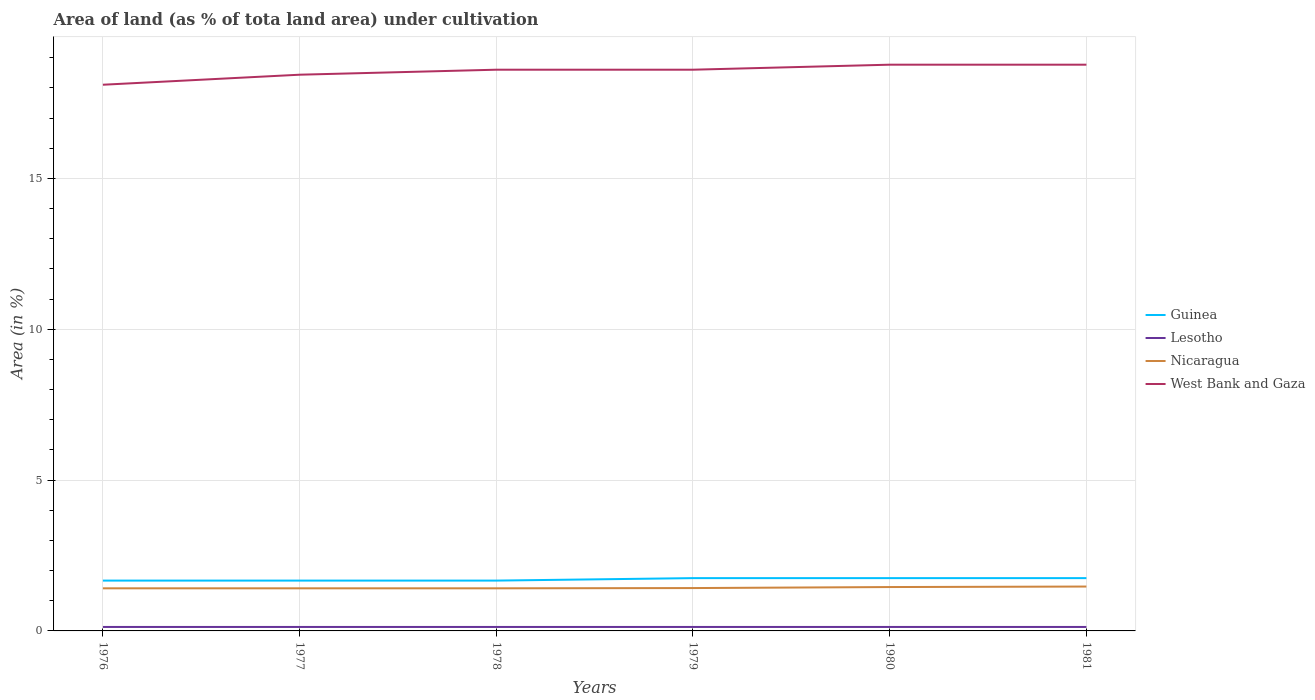Is the number of lines equal to the number of legend labels?
Your answer should be compact. Yes. Across all years, what is the maximum percentage of land under cultivation in Guinea?
Give a very brief answer. 1.67. In which year was the percentage of land under cultivation in Lesotho maximum?
Provide a succinct answer. 1976. What is the total percentage of land under cultivation in Lesotho in the graph?
Give a very brief answer. 0. What is the difference between the highest and the second highest percentage of land under cultivation in Guinea?
Your answer should be compact. 0.08. How many lines are there?
Ensure brevity in your answer.  4. Does the graph contain grids?
Keep it short and to the point. Yes. How many legend labels are there?
Your answer should be very brief. 4. What is the title of the graph?
Your answer should be very brief. Area of land (as % of tota land area) under cultivation. What is the label or title of the Y-axis?
Offer a terse response. Area (in %). What is the Area (in %) in Guinea in 1976?
Your response must be concise. 1.67. What is the Area (in %) in Lesotho in 1976?
Provide a short and direct response. 0.13. What is the Area (in %) in Nicaragua in 1976?
Your answer should be compact. 1.41. What is the Area (in %) of West Bank and Gaza in 1976?
Offer a terse response. 18.11. What is the Area (in %) of Guinea in 1977?
Ensure brevity in your answer.  1.67. What is the Area (in %) of Lesotho in 1977?
Your response must be concise. 0.13. What is the Area (in %) in Nicaragua in 1977?
Your answer should be very brief. 1.41. What is the Area (in %) of West Bank and Gaza in 1977?
Give a very brief answer. 18.44. What is the Area (in %) of Guinea in 1978?
Your answer should be compact. 1.67. What is the Area (in %) in Lesotho in 1978?
Make the answer very short. 0.13. What is the Area (in %) of Nicaragua in 1978?
Keep it short and to the point. 1.41. What is the Area (in %) of West Bank and Gaza in 1978?
Offer a terse response. 18.6. What is the Area (in %) of Guinea in 1979?
Provide a succinct answer. 1.75. What is the Area (in %) of Lesotho in 1979?
Provide a short and direct response. 0.13. What is the Area (in %) in Nicaragua in 1979?
Your response must be concise. 1.42. What is the Area (in %) in West Bank and Gaza in 1979?
Keep it short and to the point. 18.6. What is the Area (in %) of Guinea in 1980?
Your answer should be compact. 1.75. What is the Area (in %) of Lesotho in 1980?
Keep it short and to the point. 0.13. What is the Area (in %) of Nicaragua in 1980?
Keep it short and to the point. 1.45. What is the Area (in %) of West Bank and Gaza in 1980?
Offer a very short reply. 18.77. What is the Area (in %) in Guinea in 1981?
Give a very brief answer. 1.75. What is the Area (in %) of Lesotho in 1981?
Offer a very short reply. 0.13. What is the Area (in %) of Nicaragua in 1981?
Your response must be concise. 1.47. What is the Area (in %) of West Bank and Gaza in 1981?
Provide a succinct answer. 18.77. Across all years, what is the maximum Area (in %) of Guinea?
Give a very brief answer. 1.75. Across all years, what is the maximum Area (in %) in Lesotho?
Offer a very short reply. 0.13. Across all years, what is the maximum Area (in %) in Nicaragua?
Your answer should be compact. 1.47. Across all years, what is the maximum Area (in %) of West Bank and Gaza?
Ensure brevity in your answer.  18.77. Across all years, what is the minimum Area (in %) of Guinea?
Keep it short and to the point. 1.67. Across all years, what is the minimum Area (in %) of Lesotho?
Your answer should be very brief. 0.13. Across all years, what is the minimum Area (in %) of Nicaragua?
Provide a short and direct response. 1.41. Across all years, what is the minimum Area (in %) of West Bank and Gaza?
Your answer should be very brief. 18.11. What is the total Area (in %) of Guinea in the graph?
Give a very brief answer. 10.26. What is the total Area (in %) in Lesotho in the graph?
Give a very brief answer. 0.79. What is the total Area (in %) in Nicaragua in the graph?
Provide a short and direct response. 8.58. What is the total Area (in %) in West Bank and Gaza in the graph?
Provide a short and direct response. 111.3. What is the difference between the Area (in %) in Guinea in 1976 and that in 1977?
Your response must be concise. 0. What is the difference between the Area (in %) in West Bank and Gaza in 1976 and that in 1977?
Ensure brevity in your answer.  -0.33. What is the difference between the Area (in %) of Guinea in 1976 and that in 1978?
Give a very brief answer. 0. What is the difference between the Area (in %) of Lesotho in 1976 and that in 1978?
Offer a very short reply. 0. What is the difference between the Area (in %) of West Bank and Gaza in 1976 and that in 1978?
Keep it short and to the point. -0.5. What is the difference between the Area (in %) in Guinea in 1976 and that in 1979?
Give a very brief answer. -0.08. What is the difference between the Area (in %) in Nicaragua in 1976 and that in 1979?
Your answer should be very brief. -0.01. What is the difference between the Area (in %) in West Bank and Gaza in 1976 and that in 1979?
Ensure brevity in your answer.  -0.5. What is the difference between the Area (in %) of Guinea in 1976 and that in 1980?
Your answer should be compact. -0.08. What is the difference between the Area (in %) in Nicaragua in 1976 and that in 1980?
Provide a short and direct response. -0.04. What is the difference between the Area (in %) in West Bank and Gaza in 1976 and that in 1980?
Provide a succinct answer. -0.66. What is the difference between the Area (in %) in Guinea in 1976 and that in 1981?
Offer a very short reply. -0.08. What is the difference between the Area (in %) in Nicaragua in 1976 and that in 1981?
Keep it short and to the point. -0.06. What is the difference between the Area (in %) of West Bank and Gaza in 1976 and that in 1981?
Ensure brevity in your answer.  -0.66. What is the difference between the Area (in %) of West Bank and Gaza in 1977 and that in 1978?
Offer a very short reply. -0.17. What is the difference between the Area (in %) in Guinea in 1977 and that in 1979?
Provide a short and direct response. -0.08. What is the difference between the Area (in %) in Nicaragua in 1977 and that in 1979?
Give a very brief answer. -0.01. What is the difference between the Area (in %) in West Bank and Gaza in 1977 and that in 1979?
Offer a terse response. -0.17. What is the difference between the Area (in %) in Guinea in 1977 and that in 1980?
Provide a short and direct response. -0.08. What is the difference between the Area (in %) of Nicaragua in 1977 and that in 1980?
Offer a terse response. -0.04. What is the difference between the Area (in %) of West Bank and Gaza in 1977 and that in 1980?
Provide a short and direct response. -0.33. What is the difference between the Area (in %) in Guinea in 1977 and that in 1981?
Your answer should be compact. -0.08. What is the difference between the Area (in %) in Nicaragua in 1977 and that in 1981?
Your answer should be compact. -0.06. What is the difference between the Area (in %) in West Bank and Gaza in 1977 and that in 1981?
Offer a very short reply. -0.33. What is the difference between the Area (in %) of Guinea in 1978 and that in 1979?
Your answer should be compact. -0.08. What is the difference between the Area (in %) in Nicaragua in 1978 and that in 1979?
Offer a terse response. -0.01. What is the difference between the Area (in %) in West Bank and Gaza in 1978 and that in 1979?
Keep it short and to the point. 0. What is the difference between the Area (in %) of Guinea in 1978 and that in 1980?
Keep it short and to the point. -0.08. What is the difference between the Area (in %) in Nicaragua in 1978 and that in 1980?
Give a very brief answer. -0.04. What is the difference between the Area (in %) in West Bank and Gaza in 1978 and that in 1980?
Make the answer very short. -0.17. What is the difference between the Area (in %) of Guinea in 1978 and that in 1981?
Ensure brevity in your answer.  -0.08. What is the difference between the Area (in %) in Nicaragua in 1978 and that in 1981?
Give a very brief answer. -0.06. What is the difference between the Area (in %) in West Bank and Gaza in 1978 and that in 1981?
Give a very brief answer. -0.17. What is the difference between the Area (in %) in Lesotho in 1979 and that in 1980?
Give a very brief answer. 0. What is the difference between the Area (in %) of Nicaragua in 1979 and that in 1980?
Provide a short and direct response. -0.03. What is the difference between the Area (in %) of West Bank and Gaza in 1979 and that in 1980?
Offer a terse response. -0.17. What is the difference between the Area (in %) in Guinea in 1979 and that in 1981?
Provide a succinct answer. 0. What is the difference between the Area (in %) of Nicaragua in 1979 and that in 1981?
Your answer should be compact. -0.05. What is the difference between the Area (in %) of West Bank and Gaza in 1979 and that in 1981?
Provide a succinct answer. -0.17. What is the difference between the Area (in %) of Lesotho in 1980 and that in 1981?
Make the answer very short. 0. What is the difference between the Area (in %) in Nicaragua in 1980 and that in 1981?
Ensure brevity in your answer.  -0.02. What is the difference between the Area (in %) in West Bank and Gaza in 1980 and that in 1981?
Give a very brief answer. 0. What is the difference between the Area (in %) of Guinea in 1976 and the Area (in %) of Lesotho in 1977?
Offer a terse response. 1.54. What is the difference between the Area (in %) of Guinea in 1976 and the Area (in %) of Nicaragua in 1977?
Ensure brevity in your answer.  0.26. What is the difference between the Area (in %) of Guinea in 1976 and the Area (in %) of West Bank and Gaza in 1977?
Keep it short and to the point. -16.77. What is the difference between the Area (in %) in Lesotho in 1976 and the Area (in %) in Nicaragua in 1977?
Your answer should be compact. -1.28. What is the difference between the Area (in %) in Lesotho in 1976 and the Area (in %) in West Bank and Gaza in 1977?
Offer a terse response. -18.31. What is the difference between the Area (in %) in Nicaragua in 1976 and the Area (in %) in West Bank and Gaza in 1977?
Make the answer very short. -17.03. What is the difference between the Area (in %) in Guinea in 1976 and the Area (in %) in Lesotho in 1978?
Offer a terse response. 1.54. What is the difference between the Area (in %) of Guinea in 1976 and the Area (in %) of Nicaragua in 1978?
Offer a terse response. 0.26. What is the difference between the Area (in %) of Guinea in 1976 and the Area (in %) of West Bank and Gaza in 1978?
Provide a short and direct response. -16.94. What is the difference between the Area (in %) in Lesotho in 1976 and the Area (in %) in Nicaragua in 1978?
Give a very brief answer. -1.28. What is the difference between the Area (in %) in Lesotho in 1976 and the Area (in %) in West Bank and Gaza in 1978?
Make the answer very short. -18.47. What is the difference between the Area (in %) of Nicaragua in 1976 and the Area (in %) of West Bank and Gaza in 1978?
Ensure brevity in your answer.  -17.19. What is the difference between the Area (in %) in Guinea in 1976 and the Area (in %) in Lesotho in 1979?
Provide a short and direct response. 1.54. What is the difference between the Area (in %) in Guinea in 1976 and the Area (in %) in Nicaragua in 1979?
Give a very brief answer. 0.25. What is the difference between the Area (in %) of Guinea in 1976 and the Area (in %) of West Bank and Gaza in 1979?
Offer a very short reply. -16.94. What is the difference between the Area (in %) of Lesotho in 1976 and the Area (in %) of Nicaragua in 1979?
Keep it short and to the point. -1.29. What is the difference between the Area (in %) in Lesotho in 1976 and the Area (in %) in West Bank and Gaza in 1979?
Make the answer very short. -18.47. What is the difference between the Area (in %) in Nicaragua in 1976 and the Area (in %) in West Bank and Gaza in 1979?
Offer a very short reply. -17.19. What is the difference between the Area (in %) of Guinea in 1976 and the Area (in %) of Lesotho in 1980?
Provide a succinct answer. 1.54. What is the difference between the Area (in %) of Guinea in 1976 and the Area (in %) of Nicaragua in 1980?
Your response must be concise. 0.21. What is the difference between the Area (in %) of Guinea in 1976 and the Area (in %) of West Bank and Gaza in 1980?
Provide a short and direct response. -17.1. What is the difference between the Area (in %) in Lesotho in 1976 and the Area (in %) in Nicaragua in 1980?
Your answer should be compact. -1.32. What is the difference between the Area (in %) of Lesotho in 1976 and the Area (in %) of West Bank and Gaza in 1980?
Make the answer very short. -18.64. What is the difference between the Area (in %) of Nicaragua in 1976 and the Area (in %) of West Bank and Gaza in 1980?
Your response must be concise. -17.36. What is the difference between the Area (in %) in Guinea in 1976 and the Area (in %) in Lesotho in 1981?
Provide a succinct answer. 1.54. What is the difference between the Area (in %) of Guinea in 1976 and the Area (in %) of Nicaragua in 1981?
Your answer should be compact. 0.2. What is the difference between the Area (in %) of Guinea in 1976 and the Area (in %) of West Bank and Gaza in 1981?
Make the answer very short. -17.1. What is the difference between the Area (in %) in Lesotho in 1976 and the Area (in %) in Nicaragua in 1981?
Provide a succinct answer. -1.34. What is the difference between the Area (in %) of Lesotho in 1976 and the Area (in %) of West Bank and Gaza in 1981?
Provide a short and direct response. -18.64. What is the difference between the Area (in %) in Nicaragua in 1976 and the Area (in %) in West Bank and Gaza in 1981?
Offer a very short reply. -17.36. What is the difference between the Area (in %) in Guinea in 1977 and the Area (in %) in Lesotho in 1978?
Offer a very short reply. 1.54. What is the difference between the Area (in %) of Guinea in 1977 and the Area (in %) of Nicaragua in 1978?
Ensure brevity in your answer.  0.26. What is the difference between the Area (in %) in Guinea in 1977 and the Area (in %) in West Bank and Gaza in 1978?
Provide a succinct answer. -16.94. What is the difference between the Area (in %) in Lesotho in 1977 and the Area (in %) in Nicaragua in 1978?
Your answer should be compact. -1.28. What is the difference between the Area (in %) in Lesotho in 1977 and the Area (in %) in West Bank and Gaza in 1978?
Ensure brevity in your answer.  -18.47. What is the difference between the Area (in %) in Nicaragua in 1977 and the Area (in %) in West Bank and Gaza in 1978?
Provide a succinct answer. -17.19. What is the difference between the Area (in %) of Guinea in 1977 and the Area (in %) of Lesotho in 1979?
Give a very brief answer. 1.54. What is the difference between the Area (in %) in Guinea in 1977 and the Area (in %) in Nicaragua in 1979?
Provide a succinct answer. 0.25. What is the difference between the Area (in %) of Guinea in 1977 and the Area (in %) of West Bank and Gaza in 1979?
Your answer should be very brief. -16.94. What is the difference between the Area (in %) of Lesotho in 1977 and the Area (in %) of Nicaragua in 1979?
Make the answer very short. -1.29. What is the difference between the Area (in %) of Lesotho in 1977 and the Area (in %) of West Bank and Gaza in 1979?
Your response must be concise. -18.47. What is the difference between the Area (in %) of Nicaragua in 1977 and the Area (in %) of West Bank and Gaza in 1979?
Keep it short and to the point. -17.19. What is the difference between the Area (in %) of Guinea in 1977 and the Area (in %) of Lesotho in 1980?
Your response must be concise. 1.54. What is the difference between the Area (in %) in Guinea in 1977 and the Area (in %) in Nicaragua in 1980?
Ensure brevity in your answer.  0.21. What is the difference between the Area (in %) of Guinea in 1977 and the Area (in %) of West Bank and Gaza in 1980?
Your answer should be compact. -17.1. What is the difference between the Area (in %) in Lesotho in 1977 and the Area (in %) in Nicaragua in 1980?
Make the answer very short. -1.32. What is the difference between the Area (in %) of Lesotho in 1977 and the Area (in %) of West Bank and Gaza in 1980?
Your answer should be compact. -18.64. What is the difference between the Area (in %) in Nicaragua in 1977 and the Area (in %) in West Bank and Gaza in 1980?
Provide a short and direct response. -17.36. What is the difference between the Area (in %) in Guinea in 1977 and the Area (in %) in Lesotho in 1981?
Provide a succinct answer. 1.54. What is the difference between the Area (in %) of Guinea in 1977 and the Area (in %) of Nicaragua in 1981?
Give a very brief answer. 0.2. What is the difference between the Area (in %) in Guinea in 1977 and the Area (in %) in West Bank and Gaza in 1981?
Provide a succinct answer. -17.1. What is the difference between the Area (in %) in Lesotho in 1977 and the Area (in %) in Nicaragua in 1981?
Your answer should be very brief. -1.34. What is the difference between the Area (in %) of Lesotho in 1977 and the Area (in %) of West Bank and Gaza in 1981?
Provide a succinct answer. -18.64. What is the difference between the Area (in %) of Nicaragua in 1977 and the Area (in %) of West Bank and Gaza in 1981?
Your answer should be very brief. -17.36. What is the difference between the Area (in %) of Guinea in 1978 and the Area (in %) of Lesotho in 1979?
Keep it short and to the point. 1.54. What is the difference between the Area (in %) of Guinea in 1978 and the Area (in %) of Nicaragua in 1979?
Provide a short and direct response. 0.25. What is the difference between the Area (in %) in Guinea in 1978 and the Area (in %) in West Bank and Gaza in 1979?
Make the answer very short. -16.94. What is the difference between the Area (in %) of Lesotho in 1978 and the Area (in %) of Nicaragua in 1979?
Ensure brevity in your answer.  -1.29. What is the difference between the Area (in %) of Lesotho in 1978 and the Area (in %) of West Bank and Gaza in 1979?
Your answer should be compact. -18.47. What is the difference between the Area (in %) of Nicaragua in 1978 and the Area (in %) of West Bank and Gaza in 1979?
Offer a very short reply. -17.19. What is the difference between the Area (in %) of Guinea in 1978 and the Area (in %) of Lesotho in 1980?
Make the answer very short. 1.54. What is the difference between the Area (in %) of Guinea in 1978 and the Area (in %) of Nicaragua in 1980?
Your answer should be compact. 0.21. What is the difference between the Area (in %) in Guinea in 1978 and the Area (in %) in West Bank and Gaza in 1980?
Offer a terse response. -17.1. What is the difference between the Area (in %) in Lesotho in 1978 and the Area (in %) in Nicaragua in 1980?
Make the answer very short. -1.32. What is the difference between the Area (in %) of Lesotho in 1978 and the Area (in %) of West Bank and Gaza in 1980?
Give a very brief answer. -18.64. What is the difference between the Area (in %) of Nicaragua in 1978 and the Area (in %) of West Bank and Gaza in 1980?
Your answer should be compact. -17.36. What is the difference between the Area (in %) of Guinea in 1978 and the Area (in %) of Lesotho in 1981?
Offer a very short reply. 1.54. What is the difference between the Area (in %) in Guinea in 1978 and the Area (in %) in Nicaragua in 1981?
Provide a short and direct response. 0.2. What is the difference between the Area (in %) of Guinea in 1978 and the Area (in %) of West Bank and Gaza in 1981?
Keep it short and to the point. -17.1. What is the difference between the Area (in %) in Lesotho in 1978 and the Area (in %) in Nicaragua in 1981?
Keep it short and to the point. -1.34. What is the difference between the Area (in %) in Lesotho in 1978 and the Area (in %) in West Bank and Gaza in 1981?
Offer a terse response. -18.64. What is the difference between the Area (in %) of Nicaragua in 1978 and the Area (in %) of West Bank and Gaza in 1981?
Your response must be concise. -17.36. What is the difference between the Area (in %) of Guinea in 1979 and the Area (in %) of Lesotho in 1980?
Make the answer very short. 1.62. What is the difference between the Area (in %) in Guinea in 1979 and the Area (in %) in Nicaragua in 1980?
Your answer should be very brief. 0.3. What is the difference between the Area (in %) in Guinea in 1979 and the Area (in %) in West Bank and Gaza in 1980?
Offer a very short reply. -17.02. What is the difference between the Area (in %) in Lesotho in 1979 and the Area (in %) in Nicaragua in 1980?
Provide a succinct answer. -1.32. What is the difference between the Area (in %) in Lesotho in 1979 and the Area (in %) in West Bank and Gaza in 1980?
Provide a short and direct response. -18.64. What is the difference between the Area (in %) of Nicaragua in 1979 and the Area (in %) of West Bank and Gaza in 1980?
Your response must be concise. -17.35. What is the difference between the Area (in %) of Guinea in 1979 and the Area (in %) of Lesotho in 1981?
Ensure brevity in your answer.  1.62. What is the difference between the Area (in %) in Guinea in 1979 and the Area (in %) in Nicaragua in 1981?
Your response must be concise. 0.28. What is the difference between the Area (in %) in Guinea in 1979 and the Area (in %) in West Bank and Gaza in 1981?
Provide a short and direct response. -17.02. What is the difference between the Area (in %) in Lesotho in 1979 and the Area (in %) in Nicaragua in 1981?
Give a very brief answer. -1.34. What is the difference between the Area (in %) in Lesotho in 1979 and the Area (in %) in West Bank and Gaza in 1981?
Your answer should be compact. -18.64. What is the difference between the Area (in %) of Nicaragua in 1979 and the Area (in %) of West Bank and Gaza in 1981?
Ensure brevity in your answer.  -17.35. What is the difference between the Area (in %) of Guinea in 1980 and the Area (in %) of Lesotho in 1981?
Your answer should be very brief. 1.62. What is the difference between the Area (in %) of Guinea in 1980 and the Area (in %) of Nicaragua in 1981?
Offer a very short reply. 0.28. What is the difference between the Area (in %) in Guinea in 1980 and the Area (in %) in West Bank and Gaza in 1981?
Offer a very short reply. -17.02. What is the difference between the Area (in %) of Lesotho in 1980 and the Area (in %) of Nicaragua in 1981?
Give a very brief answer. -1.34. What is the difference between the Area (in %) in Lesotho in 1980 and the Area (in %) in West Bank and Gaza in 1981?
Keep it short and to the point. -18.64. What is the difference between the Area (in %) of Nicaragua in 1980 and the Area (in %) of West Bank and Gaza in 1981?
Provide a succinct answer. -17.32. What is the average Area (in %) of Guinea per year?
Ensure brevity in your answer.  1.71. What is the average Area (in %) of Lesotho per year?
Ensure brevity in your answer.  0.13. What is the average Area (in %) of Nicaragua per year?
Offer a terse response. 1.43. What is the average Area (in %) in West Bank and Gaza per year?
Make the answer very short. 18.55. In the year 1976, what is the difference between the Area (in %) in Guinea and Area (in %) in Lesotho?
Give a very brief answer. 1.54. In the year 1976, what is the difference between the Area (in %) in Guinea and Area (in %) in Nicaragua?
Provide a succinct answer. 0.26. In the year 1976, what is the difference between the Area (in %) of Guinea and Area (in %) of West Bank and Gaza?
Your answer should be very brief. -16.44. In the year 1976, what is the difference between the Area (in %) in Lesotho and Area (in %) in Nicaragua?
Keep it short and to the point. -1.28. In the year 1976, what is the difference between the Area (in %) of Lesotho and Area (in %) of West Bank and Gaza?
Offer a terse response. -17.97. In the year 1976, what is the difference between the Area (in %) of Nicaragua and Area (in %) of West Bank and Gaza?
Provide a succinct answer. -16.69. In the year 1977, what is the difference between the Area (in %) of Guinea and Area (in %) of Lesotho?
Keep it short and to the point. 1.54. In the year 1977, what is the difference between the Area (in %) of Guinea and Area (in %) of Nicaragua?
Your answer should be very brief. 0.26. In the year 1977, what is the difference between the Area (in %) in Guinea and Area (in %) in West Bank and Gaza?
Offer a terse response. -16.77. In the year 1977, what is the difference between the Area (in %) in Lesotho and Area (in %) in Nicaragua?
Give a very brief answer. -1.28. In the year 1977, what is the difference between the Area (in %) of Lesotho and Area (in %) of West Bank and Gaza?
Ensure brevity in your answer.  -18.31. In the year 1977, what is the difference between the Area (in %) in Nicaragua and Area (in %) in West Bank and Gaza?
Ensure brevity in your answer.  -17.03. In the year 1978, what is the difference between the Area (in %) of Guinea and Area (in %) of Lesotho?
Ensure brevity in your answer.  1.54. In the year 1978, what is the difference between the Area (in %) in Guinea and Area (in %) in Nicaragua?
Offer a terse response. 0.26. In the year 1978, what is the difference between the Area (in %) of Guinea and Area (in %) of West Bank and Gaza?
Offer a terse response. -16.94. In the year 1978, what is the difference between the Area (in %) of Lesotho and Area (in %) of Nicaragua?
Keep it short and to the point. -1.28. In the year 1978, what is the difference between the Area (in %) of Lesotho and Area (in %) of West Bank and Gaza?
Keep it short and to the point. -18.47. In the year 1978, what is the difference between the Area (in %) of Nicaragua and Area (in %) of West Bank and Gaza?
Offer a terse response. -17.19. In the year 1979, what is the difference between the Area (in %) in Guinea and Area (in %) in Lesotho?
Give a very brief answer. 1.62. In the year 1979, what is the difference between the Area (in %) in Guinea and Area (in %) in Nicaragua?
Provide a succinct answer. 0.33. In the year 1979, what is the difference between the Area (in %) in Guinea and Area (in %) in West Bank and Gaza?
Give a very brief answer. -16.85. In the year 1979, what is the difference between the Area (in %) of Lesotho and Area (in %) of Nicaragua?
Ensure brevity in your answer.  -1.29. In the year 1979, what is the difference between the Area (in %) in Lesotho and Area (in %) in West Bank and Gaza?
Give a very brief answer. -18.47. In the year 1979, what is the difference between the Area (in %) in Nicaragua and Area (in %) in West Bank and Gaza?
Keep it short and to the point. -17.18. In the year 1980, what is the difference between the Area (in %) in Guinea and Area (in %) in Lesotho?
Offer a very short reply. 1.62. In the year 1980, what is the difference between the Area (in %) in Guinea and Area (in %) in Nicaragua?
Your response must be concise. 0.3. In the year 1980, what is the difference between the Area (in %) of Guinea and Area (in %) of West Bank and Gaza?
Provide a short and direct response. -17.02. In the year 1980, what is the difference between the Area (in %) in Lesotho and Area (in %) in Nicaragua?
Offer a terse response. -1.32. In the year 1980, what is the difference between the Area (in %) in Lesotho and Area (in %) in West Bank and Gaza?
Your answer should be very brief. -18.64. In the year 1980, what is the difference between the Area (in %) of Nicaragua and Area (in %) of West Bank and Gaza?
Ensure brevity in your answer.  -17.32. In the year 1981, what is the difference between the Area (in %) in Guinea and Area (in %) in Lesotho?
Give a very brief answer. 1.62. In the year 1981, what is the difference between the Area (in %) of Guinea and Area (in %) of Nicaragua?
Your answer should be very brief. 0.28. In the year 1981, what is the difference between the Area (in %) in Guinea and Area (in %) in West Bank and Gaza?
Your response must be concise. -17.02. In the year 1981, what is the difference between the Area (in %) in Lesotho and Area (in %) in Nicaragua?
Ensure brevity in your answer.  -1.34. In the year 1981, what is the difference between the Area (in %) of Lesotho and Area (in %) of West Bank and Gaza?
Offer a very short reply. -18.64. In the year 1981, what is the difference between the Area (in %) in Nicaragua and Area (in %) in West Bank and Gaza?
Offer a very short reply. -17.3. What is the ratio of the Area (in %) in Guinea in 1976 to that in 1977?
Offer a terse response. 1. What is the ratio of the Area (in %) of Nicaragua in 1976 to that in 1977?
Provide a succinct answer. 1. What is the ratio of the Area (in %) in West Bank and Gaza in 1976 to that in 1977?
Provide a short and direct response. 0.98. What is the ratio of the Area (in %) of Guinea in 1976 to that in 1978?
Offer a very short reply. 1. What is the ratio of the Area (in %) of Nicaragua in 1976 to that in 1978?
Make the answer very short. 1. What is the ratio of the Area (in %) in West Bank and Gaza in 1976 to that in 1978?
Give a very brief answer. 0.97. What is the ratio of the Area (in %) of Guinea in 1976 to that in 1979?
Offer a terse response. 0.95. What is the ratio of the Area (in %) in Lesotho in 1976 to that in 1979?
Your answer should be compact. 1. What is the ratio of the Area (in %) of Nicaragua in 1976 to that in 1979?
Make the answer very short. 0.99. What is the ratio of the Area (in %) of West Bank and Gaza in 1976 to that in 1979?
Give a very brief answer. 0.97. What is the ratio of the Area (in %) in Guinea in 1976 to that in 1980?
Your answer should be compact. 0.95. What is the ratio of the Area (in %) of Nicaragua in 1976 to that in 1980?
Give a very brief answer. 0.97. What is the ratio of the Area (in %) in West Bank and Gaza in 1976 to that in 1980?
Your response must be concise. 0.96. What is the ratio of the Area (in %) in Guinea in 1976 to that in 1981?
Make the answer very short. 0.95. What is the ratio of the Area (in %) of Lesotho in 1976 to that in 1981?
Provide a short and direct response. 1. What is the ratio of the Area (in %) in Nicaragua in 1976 to that in 1981?
Offer a very short reply. 0.96. What is the ratio of the Area (in %) of West Bank and Gaza in 1976 to that in 1981?
Your answer should be very brief. 0.96. What is the ratio of the Area (in %) in Lesotho in 1977 to that in 1978?
Make the answer very short. 1. What is the ratio of the Area (in %) of West Bank and Gaza in 1977 to that in 1978?
Make the answer very short. 0.99. What is the ratio of the Area (in %) in Guinea in 1977 to that in 1979?
Give a very brief answer. 0.95. What is the ratio of the Area (in %) of Lesotho in 1977 to that in 1979?
Ensure brevity in your answer.  1. What is the ratio of the Area (in %) in Guinea in 1977 to that in 1980?
Your response must be concise. 0.95. What is the ratio of the Area (in %) of Nicaragua in 1977 to that in 1980?
Your answer should be very brief. 0.97. What is the ratio of the Area (in %) of West Bank and Gaza in 1977 to that in 1980?
Your answer should be compact. 0.98. What is the ratio of the Area (in %) in Guinea in 1977 to that in 1981?
Your answer should be compact. 0.95. What is the ratio of the Area (in %) in Nicaragua in 1977 to that in 1981?
Your response must be concise. 0.96. What is the ratio of the Area (in %) in West Bank and Gaza in 1977 to that in 1981?
Offer a very short reply. 0.98. What is the ratio of the Area (in %) in Guinea in 1978 to that in 1979?
Your response must be concise. 0.95. What is the ratio of the Area (in %) of Lesotho in 1978 to that in 1979?
Ensure brevity in your answer.  1. What is the ratio of the Area (in %) of Guinea in 1978 to that in 1980?
Make the answer very short. 0.95. What is the ratio of the Area (in %) in Nicaragua in 1978 to that in 1980?
Your response must be concise. 0.97. What is the ratio of the Area (in %) in West Bank and Gaza in 1978 to that in 1980?
Your response must be concise. 0.99. What is the ratio of the Area (in %) of Guinea in 1978 to that in 1981?
Your answer should be very brief. 0.95. What is the ratio of the Area (in %) in Nicaragua in 1978 to that in 1981?
Your response must be concise. 0.96. What is the ratio of the Area (in %) in West Bank and Gaza in 1978 to that in 1981?
Your answer should be compact. 0.99. What is the ratio of the Area (in %) of Lesotho in 1979 to that in 1980?
Provide a succinct answer. 1. What is the ratio of the Area (in %) of Nicaragua in 1979 to that in 1980?
Give a very brief answer. 0.98. What is the ratio of the Area (in %) in Lesotho in 1979 to that in 1981?
Your answer should be compact. 1. What is the ratio of the Area (in %) of Nicaragua in 1979 to that in 1981?
Provide a short and direct response. 0.97. What is the ratio of the Area (in %) in West Bank and Gaza in 1979 to that in 1981?
Offer a very short reply. 0.99. What is the ratio of the Area (in %) of Nicaragua in 1980 to that in 1981?
Your answer should be compact. 0.99. What is the difference between the highest and the second highest Area (in %) in Nicaragua?
Ensure brevity in your answer.  0.02. What is the difference between the highest and the second highest Area (in %) of West Bank and Gaza?
Provide a succinct answer. 0. What is the difference between the highest and the lowest Area (in %) in Guinea?
Your answer should be very brief. 0.08. What is the difference between the highest and the lowest Area (in %) of Nicaragua?
Ensure brevity in your answer.  0.06. What is the difference between the highest and the lowest Area (in %) in West Bank and Gaza?
Provide a short and direct response. 0.66. 